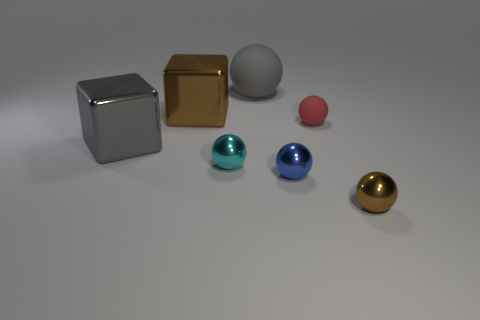Is the number of small cyan things less than the number of blue cylinders?
Your response must be concise. No. There is a big thing that is right of the cyan metal object; what color is it?
Provide a succinct answer. Gray. There is a large thing that is in front of the large rubber thing and behind the red object; what is it made of?
Keep it short and to the point. Metal. There is a blue thing that is made of the same material as the tiny cyan sphere; what shape is it?
Make the answer very short. Sphere. What number of tiny rubber spheres are to the left of the brown thing in front of the cyan object?
Your answer should be compact. 1. How many objects are both behind the blue thing and on the left side of the red thing?
Your answer should be compact. 4. What number of other objects are there of the same material as the red ball?
Provide a succinct answer. 1. The tiny sphere to the left of the large gray matte ball that is behind the tiny cyan sphere is what color?
Make the answer very short. Cyan. Do the large cube in front of the big brown block and the big ball have the same color?
Offer a very short reply. Yes. Is the brown block the same size as the cyan thing?
Provide a succinct answer. No. 